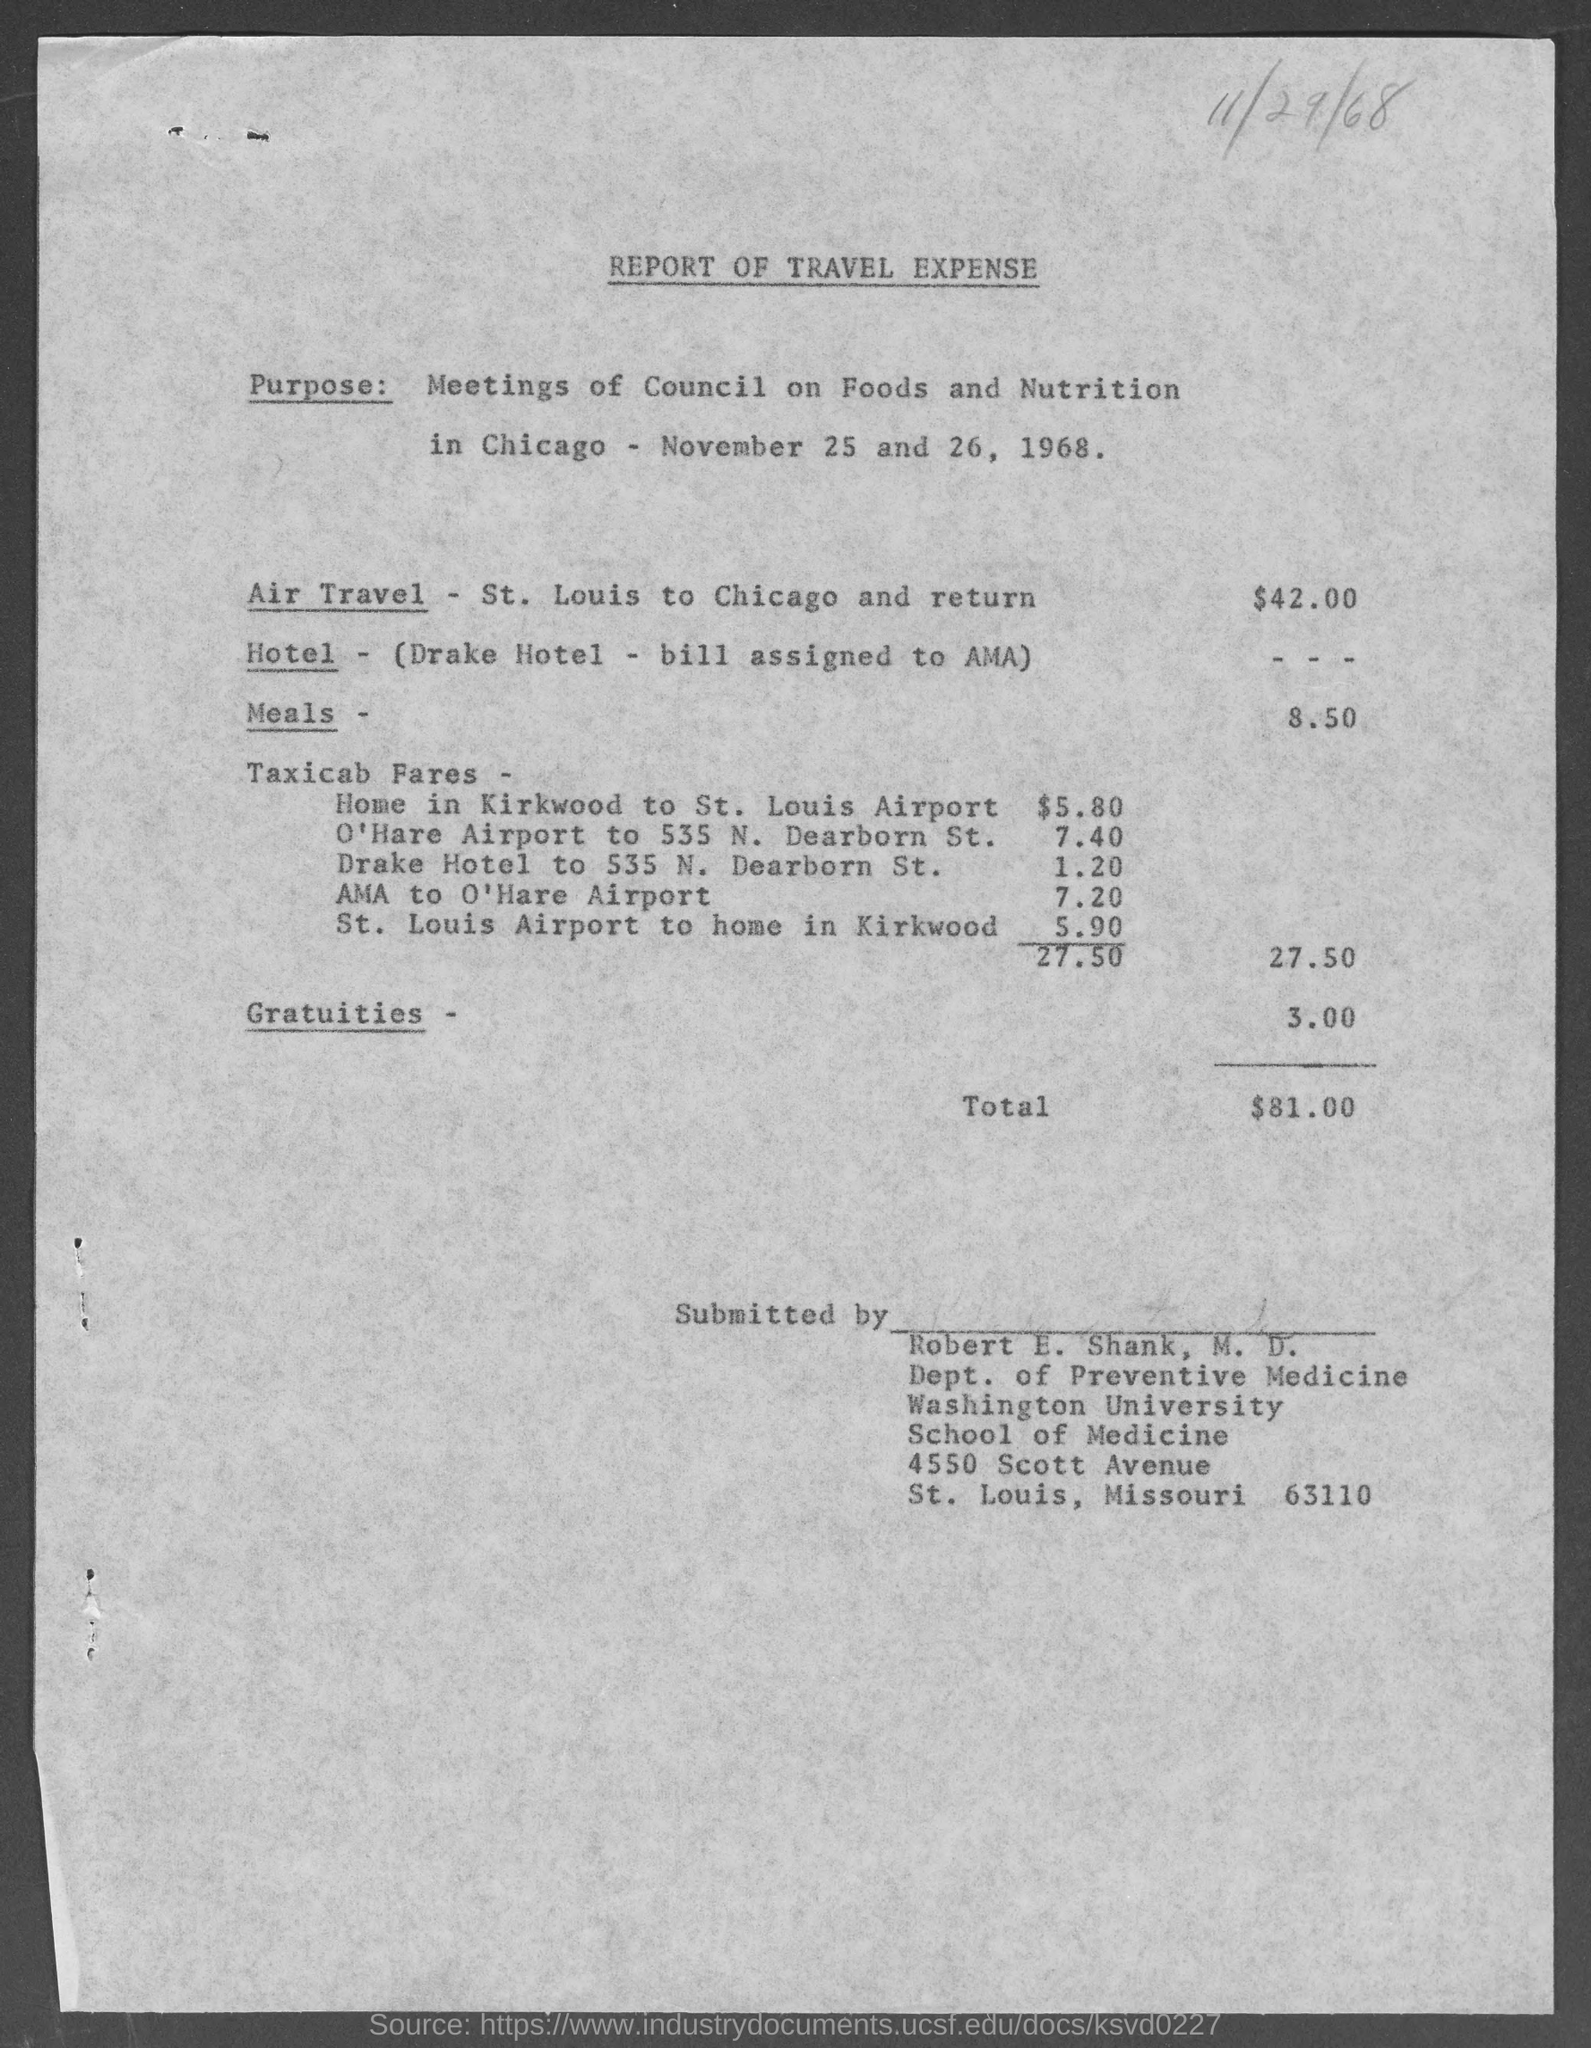What is the total amount ?
Offer a very short reply. $81.00. What is the street address of washington university school of medicine ?
Offer a terse response. 4550 Scott Avenue. Who submitted the report?
Your answer should be very brief. Robert E. Shank, M.D. 